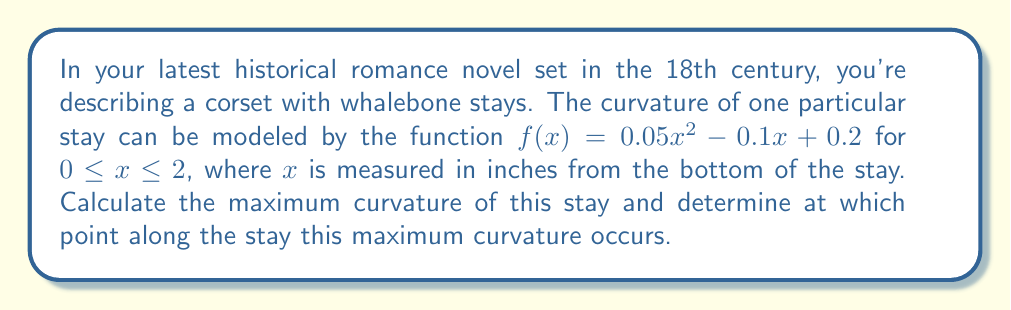Help me with this question. To solve this problem, we'll follow these steps:

1) The curvature $\kappa$ of a function $y = f(x)$ is given by the formula:

   $$\kappa = \frac{|f''(x)|}{(1 + (f'(x))^2)^{3/2}}$$

2) First, let's find $f'(x)$ and $f''(x)$:
   
   $f'(x) = 0.1x - 0.1$
   $f''(x) = 0.1$

3) Now, we can substitute these into our curvature formula:

   $$\kappa = \frac{|0.1|}{(1 + (0.1x - 0.1)^2)^{3/2}}$$

4) To find the maximum curvature, we need to find where the derivative of $\kappa$ with respect to $x$ is zero. However, we can see that the numerator is constant, and the denominator is smallest when $(0.1x - 0.1)^2$ is smallest, which occurs when $0.1x - 0.1 = 0$.

5) Solving $0.1x - 0.1 = 0$:
   
   $0.1x = 0.1$
   $x = 1$

6) This means the maximum curvature occurs at $x = 1$ inch from the bottom of the stay.

7) To calculate the maximum curvature, we substitute $x = 1$ into our curvature formula:

   $$\kappa_{max} = \frac{|0.1|}{(1 + (0.1(1) - 0.1)^2)^{3/2}} = \frac{0.1}{1^{3/2}} = 0.1$$

Therefore, the maximum curvature is 0.1 and it occurs 1 inch from the bottom of the stay.
Answer: The maximum curvature is 0.1, occurring at 1 inch from the bottom of the stay. 